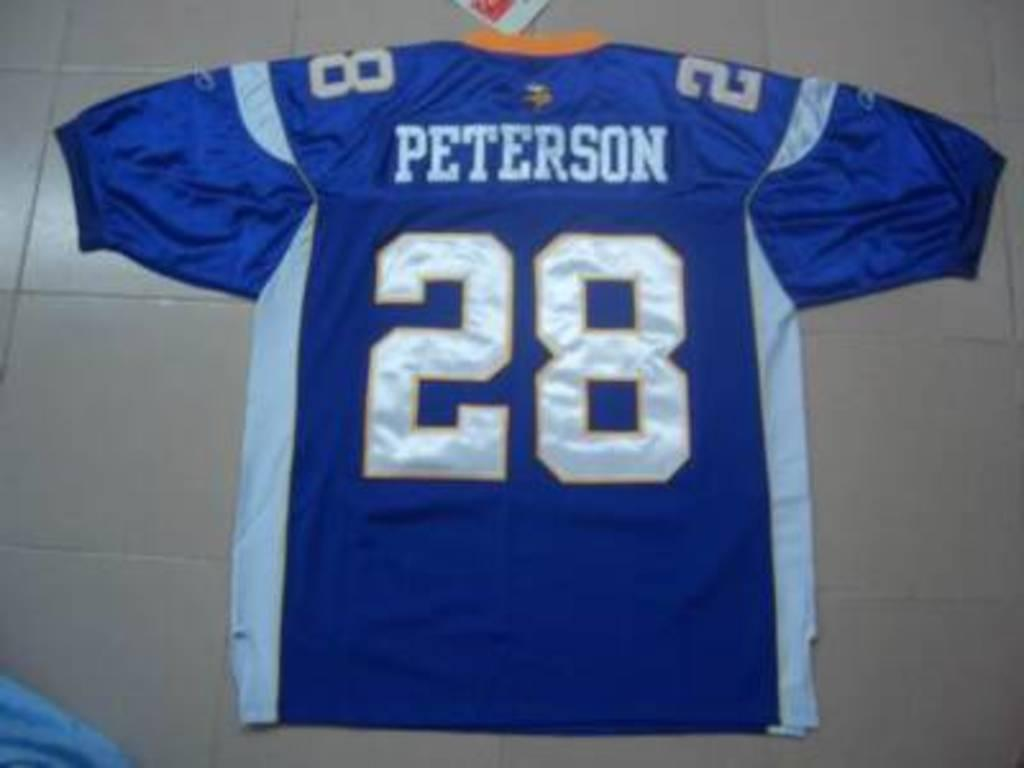<image>
Offer a succinct explanation of the picture presented. the number 28 is on the back of a jersey 